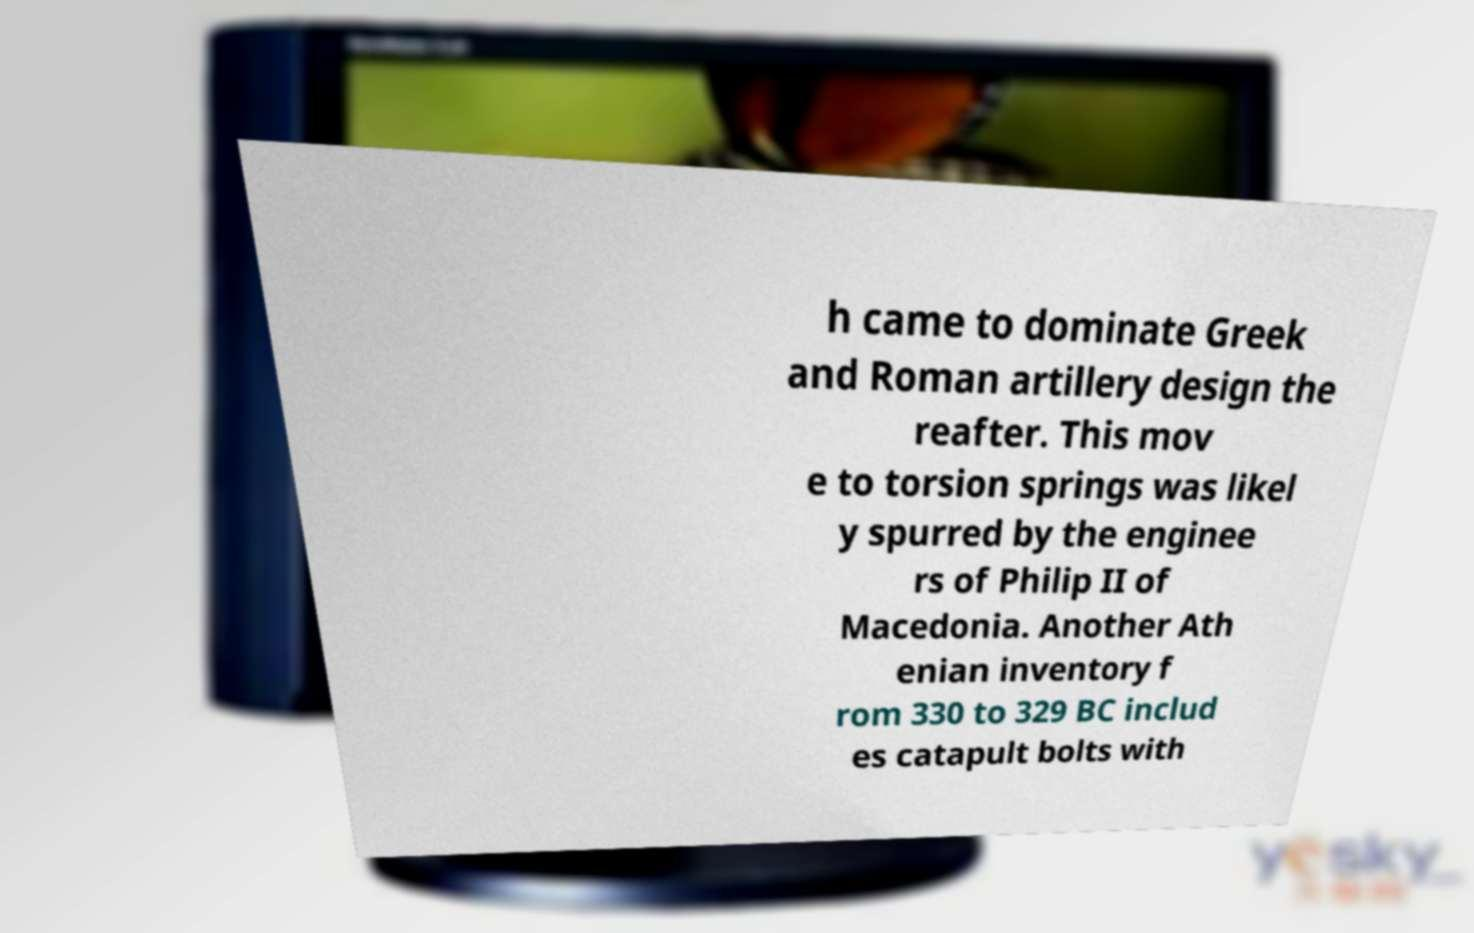Can you read and provide the text displayed in the image?This photo seems to have some interesting text. Can you extract and type it out for me? h came to dominate Greek and Roman artillery design the reafter. This mov e to torsion springs was likel y spurred by the enginee rs of Philip II of Macedonia. Another Ath enian inventory f rom 330 to 329 BC includ es catapult bolts with 